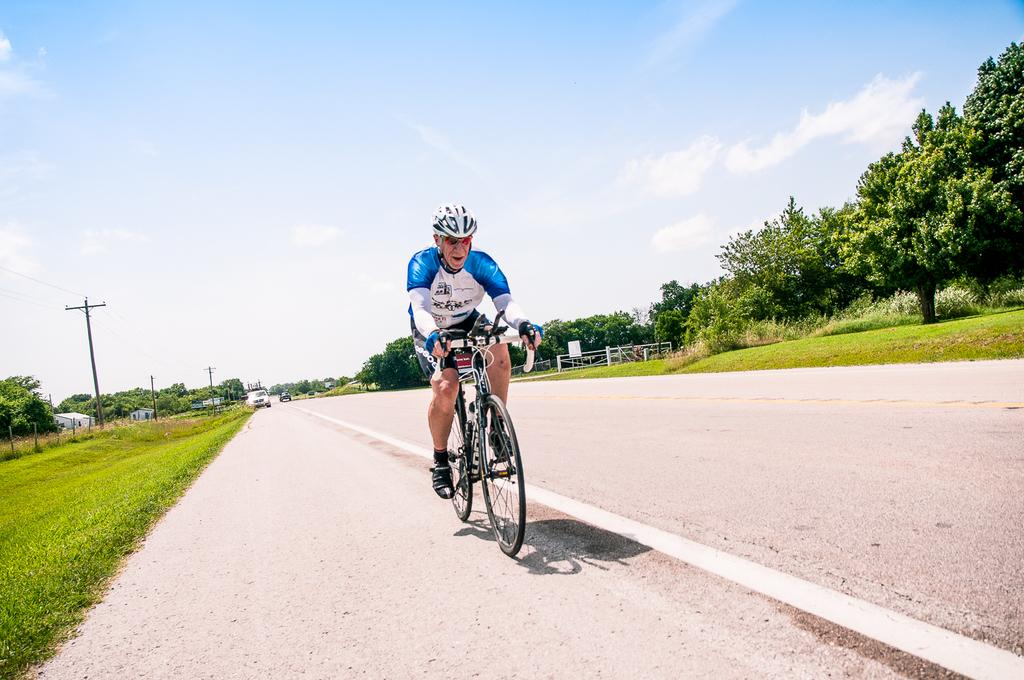What is the man in the image doing? The man is riding a cycle in the image. Where is the man riding the cycle? The man is on the road. What can be seen behind the man while he is riding the cycle? There are vehicles behind the man. What type of vegetation is present around the road? There is grass and trees around the road. What structures are present around the road? There are poles around the road. What type of business is the man conducting while walking on the road? The image does not show the man walking or conducting any business; he is riding a cycle. 